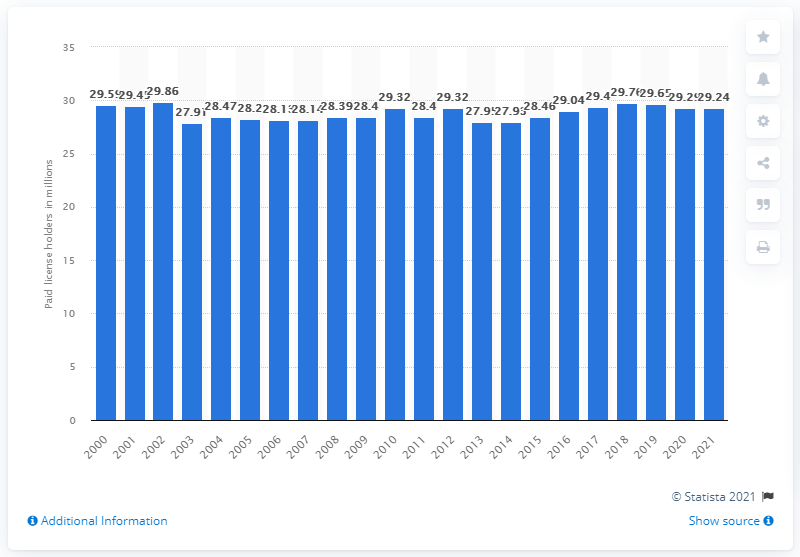Highlight a few significant elements in this photo. In 2021, there were 29,240 paid fishing license holders in the United States. 